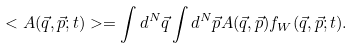<formula> <loc_0><loc_0><loc_500><loc_500>< A ( \vec { q } , \vec { p } ; t ) > = \int d ^ { N } \vec { q } \int d ^ { N } \vec { p } A ( \vec { q } , \vec { p } ) f _ { W } ( \vec { q } , \vec { p } ; t ) .</formula> 